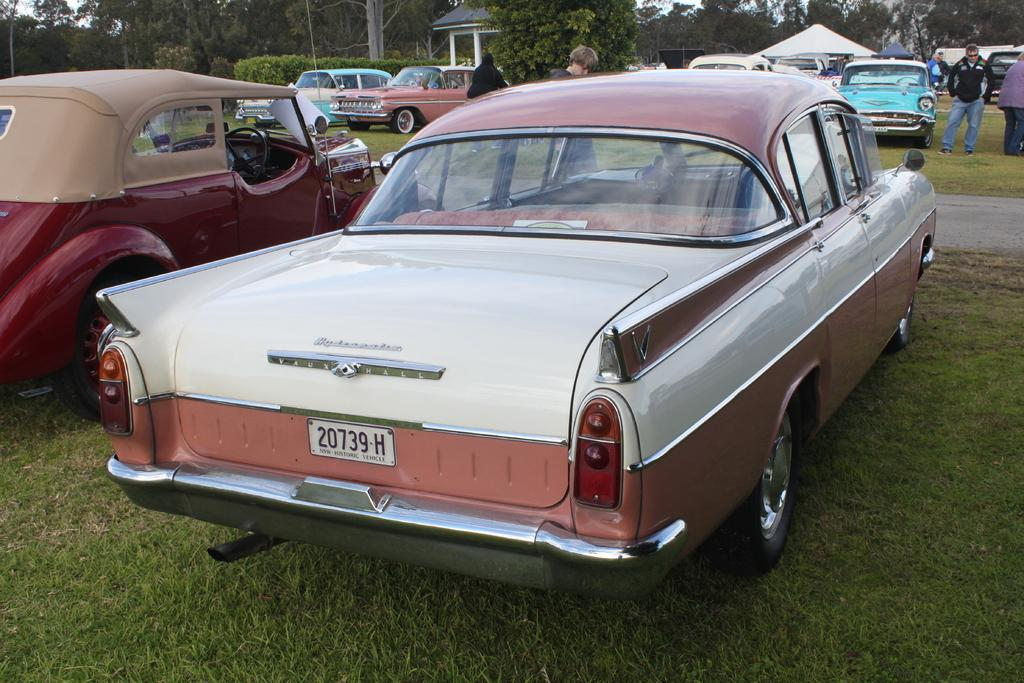What is happening with the vehicles in the image? There are vehicles parked on the path in the image. Can you describe the position of some of the vehicles? Some vehicles are standing in the image. What can be seen in the background of the image? There is a stall visible in the background of the image, as well as trees and the sky. What type of drug can be seen in the hands of the brothers in the image? There are no brothers or drugs present in the image. What sound do the vehicles make in the image? The vehicles do not make any sounds in the image, as it is a still image. 